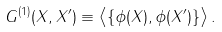Convert formula to latex. <formula><loc_0><loc_0><loc_500><loc_500>G ^ { ( 1 ) } ( X , X ^ { \prime } ) \equiv \left \langle \{ \phi ( X ) , \phi ( X ^ { \prime } ) \} \right \rangle .</formula> 